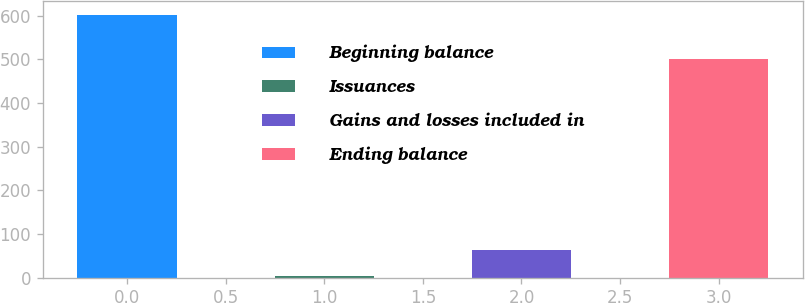<chart> <loc_0><loc_0><loc_500><loc_500><bar_chart><fcel>Beginning balance<fcel>Issuances<fcel>Gains and losses included in<fcel>Ending balance<nl><fcel>602.9<fcel>3.8<fcel>63.71<fcel>500.9<nl></chart> 